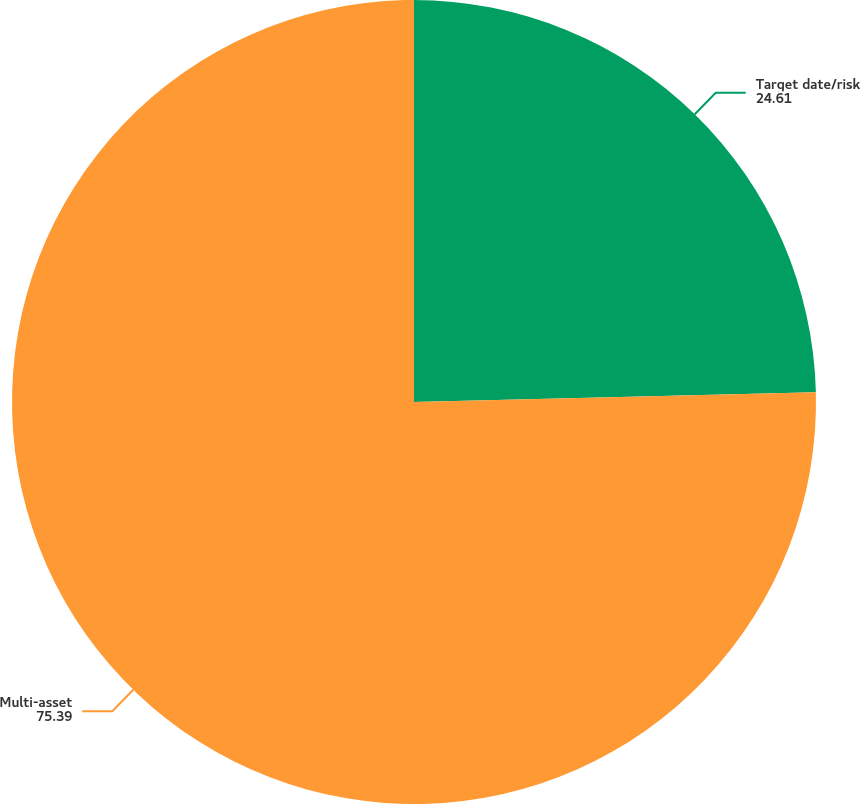Convert chart to OTSL. <chart><loc_0><loc_0><loc_500><loc_500><pie_chart><fcel>Target date/risk<fcel>Multi-asset<nl><fcel>24.61%<fcel>75.39%<nl></chart> 